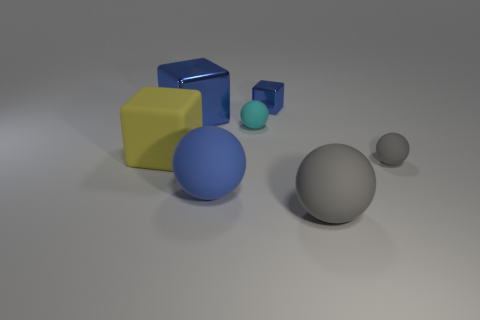Subtract all big blue matte spheres. How many spheres are left? 3 Add 1 tiny cyan things. How many objects exist? 8 Subtract all blue spheres. How many blue blocks are left? 2 Subtract all blue blocks. How many blocks are left? 1 Subtract all brown spheres. Subtract all yellow cylinders. How many spheres are left? 4 Subtract all big gray balls. Subtract all big yellow matte cubes. How many objects are left? 5 Add 2 big metallic cubes. How many big metallic cubes are left? 3 Add 6 tiny rubber things. How many tiny rubber things exist? 8 Subtract 0 yellow spheres. How many objects are left? 7 Subtract all cubes. How many objects are left? 4 